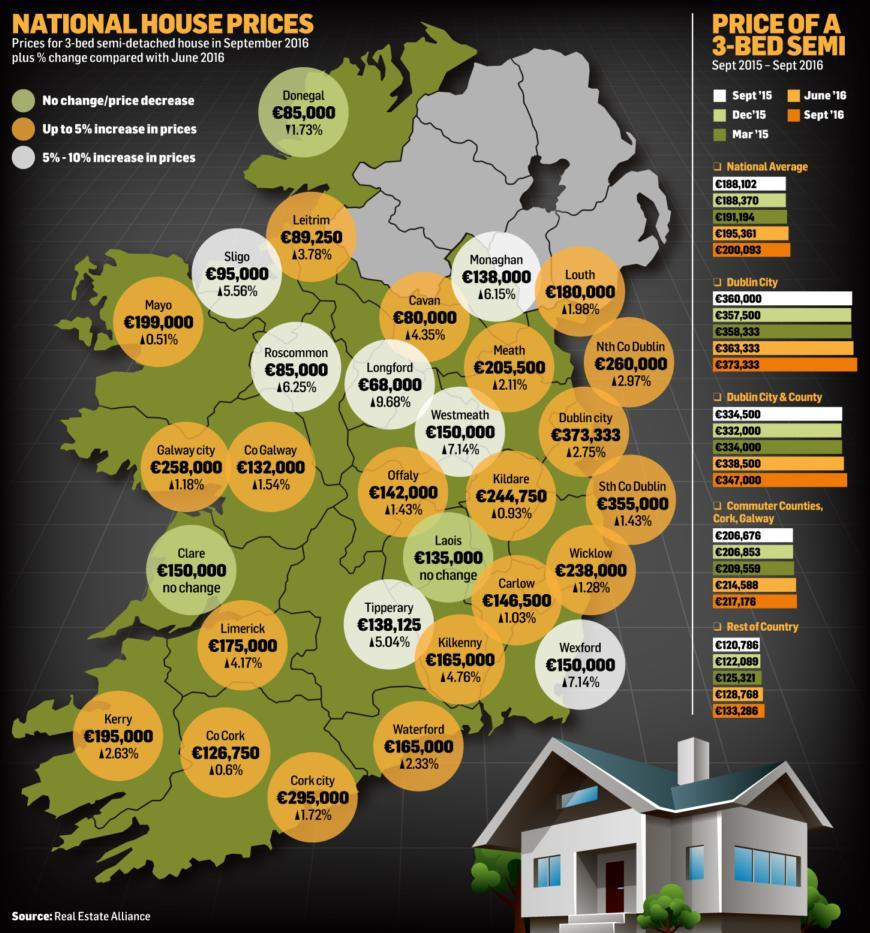When compared with June 2016, which cities show a price increase between 5%-6%?
Answer the question with a short phrase. Sligo, Tipperary What is the price of houses in Dublin city as on September 2016(€)? 373,333 How many cities show a % increase in prices between 5% to 10%? 7 What was the national average house prices in March 2015(€)? 191,194 What is the price of houses in Sligo in September 2016(€)? 95,000 By how much is the house price in Dublin City higher than in Longford(€)? 305,333 Which city has the lowest house prices in September 2016? Longford What was the increase in the national average price of a 3-bed semi in September 2016 when compared to March 2015 (€)? 8,899 Which city has the highest % increase in house prices in September 2016, when compared with June 2016? Longford Which is the only city that shows a decrease in house prices in September 2016? Donegal What is the % increase in house prices in Longford, when compared to June 2016? 9.68% When compared with June 2016, which cities show a price increase of above 7%? Wexford, Longford, Westmeath What was the price of 3 bed semi in Dublin city in March 2015(€)? 358,333 What is the % increase in house prices in Sligo since June 2016 ? 5.56% Which cities show no change in house prices in September 2016, when compared to June 2016? Clare, Laois What is the national average house price in September 2016 (€)? 200,093 Which city has the highest house prices in September 2016? Dublin City 